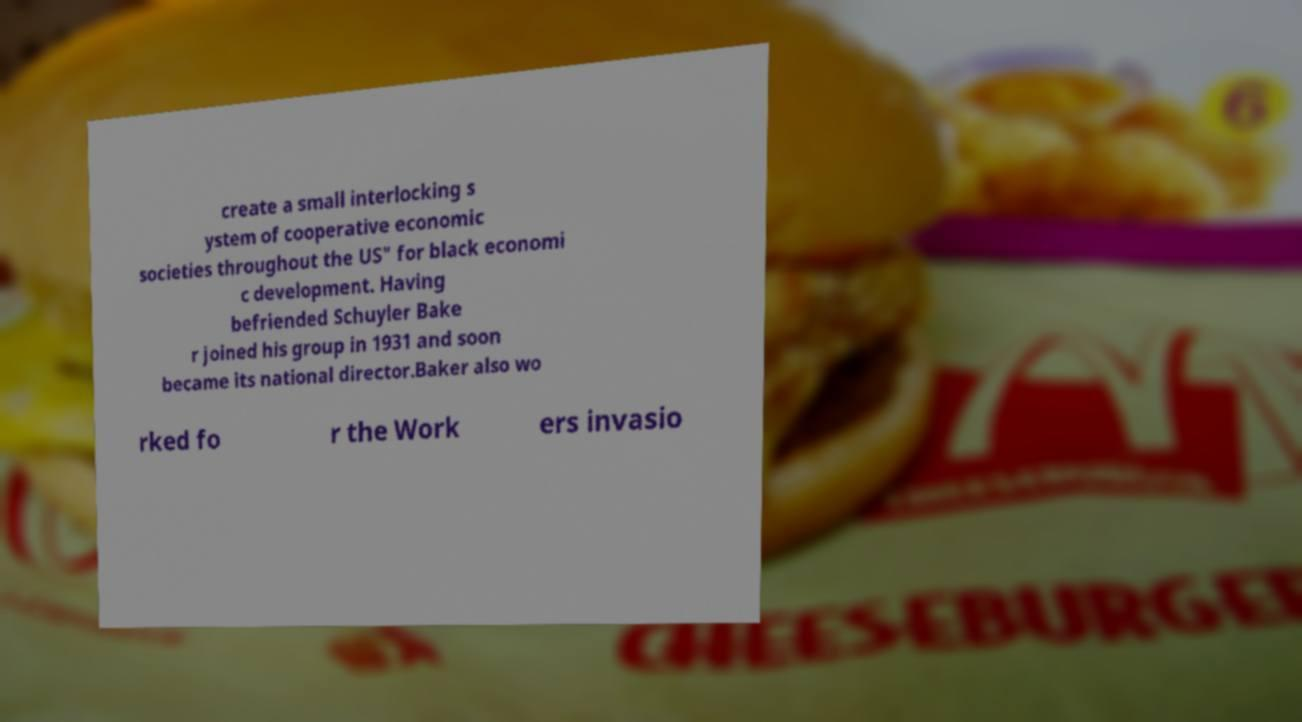Please read and relay the text visible in this image. What does it say? create a small interlocking s ystem of cooperative economic societies throughout the US" for black economi c development. Having befriended Schuyler Bake r joined his group in 1931 and soon became its national director.Baker also wo rked fo r the Work ers invasio 